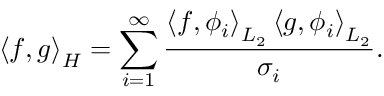<formula> <loc_0><loc_0><loc_500><loc_500>\left \langle f , g \right \rangle _ { H } = \sum _ { i = 1 } ^ { \infty } { \frac { \left \langle f , \phi _ { i } \right \rangle _ { L _ { 2 } } \left \langle g , \phi _ { i } \right \rangle _ { L _ { 2 } } } { \sigma _ { i } } } .</formula> 